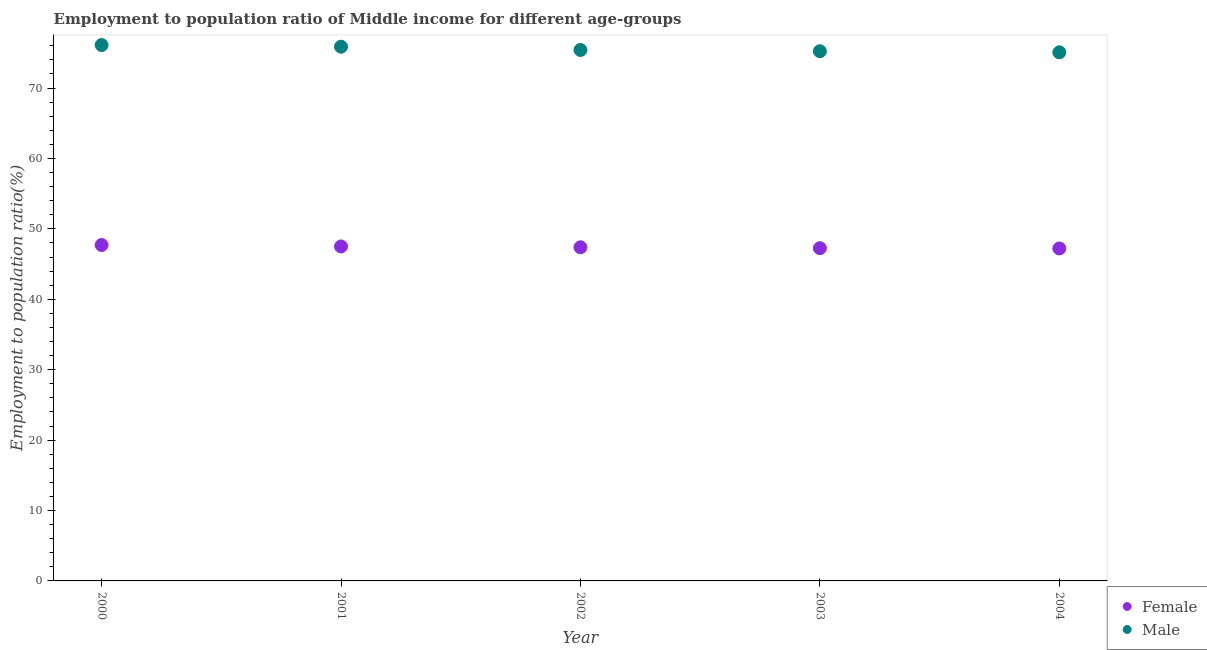What is the employment to population ratio(female) in 2001?
Give a very brief answer. 47.51. Across all years, what is the maximum employment to population ratio(male)?
Provide a succinct answer. 76.11. Across all years, what is the minimum employment to population ratio(male)?
Provide a succinct answer. 75.07. In which year was the employment to population ratio(female) maximum?
Offer a very short reply. 2000. In which year was the employment to population ratio(male) minimum?
Provide a short and direct response. 2004. What is the total employment to population ratio(female) in the graph?
Provide a short and direct response. 237.08. What is the difference between the employment to population ratio(female) in 2002 and that in 2003?
Ensure brevity in your answer.  0.13. What is the difference between the employment to population ratio(female) in 2001 and the employment to population ratio(male) in 2002?
Offer a terse response. -27.9. What is the average employment to population ratio(female) per year?
Make the answer very short. 47.42. In the year 2000, what is the difference between the employment to population ratio(female) and employment to population ratio(male)?
Provide a succinct answer. -28.4. What is the ratio of the employment to population ratio(male) in 2000 to that in 2003?
Provide a succinct answer. 1.01. Is the employment to population ratio(female) in 2000 less than that in 2004?
Your response must be concise. No. What is the difference between the highest and the second highest employment to population ratio(female)?
Offer a very short reply. 0.2. What is the difference between the highest and the lowest employment to population ratio(female)?
Provide a succinct answer. 0.49. Is the sum of the employment to population ratio(male) in 2001 and 2002 greater than the maximum employment to population ratio(female) across all years?
Offer a terse response. Yes. Does the employment to population ratio(female) monotonically increase over the years?
Your answer should be very brief. No. Is the employment to population ratio(male) strictly less than the employment to population ratio(female) over the years?
Your answer should be very brief. No. How many dotlines are there?
Ensure brevity in your answer.  2. How many years are there in the graph?
Keep it short and to the point. 5. Does the graph contain any zero values?
Offer a terse response. No. Does the graph contain grids?
Offer a terse response. No. Where does the legend appear in the graph?
Make the answer very short. Bottom right. How many legend labels are there?
Your answer should be compact. 2. How are the legend labels stacked?
Your answer should be very brief. Vertical. What is the title of the graph?
Keep it short and to the point. Employment to population ratio of Middle income for different age-groups. Does "Urban Population" appear as one of the legend labels in the graph?
Offer a very short reply. No. What is the label or title of the X-axis?
Your response must be concise. Year. What is the label or title of the Y-axis?
Give a very brief answer. Employment to population ratio(%). What is the Employment to population ratio(%) in Female in 2000?
Provide a short and direct response. 47.71. What is the Employment to population ratio(%) in Male in 2000?
Ensure brevity in your answer.  76.11. What is the Employment to population ratio(%) in Female in 2001?
Give a very brief answer. 47.51. What is the Employment to population ratio(%) in Male in 2001?
Make the answer very short. 75.88. What is the Employment to population ratio(%) in Female in 2002?
Your answer should be very brief. 47.39. What is the Employment to population ratio(%) in Male in 2002?
Keep it short and to the point. 75.41. What is the Employment to population ratio(%) in Female in 2003?
Your answer should be compact. 47.26. What is the Employment to population ratio(%) in Male in 2003?
Offer a terse response. 75.23. What is the Employment to population ratio(%) in Female in 2004?
Provide a succinct answer. 47.22. What is the Employment to population ratio(%) in Male in 2004?
Make the answer very short. 75.07. Across all years, what is the maximum Employment to population ratio(%) in Female?
Your answer should be very brief. 47.71. Across all years, what is the maximum Employment to population ratio(%) in Male?
Provide a succinct answer. 76.11. Across all years, what is the minimum Employment to population ratio(%) of Female?
Your answer should be very brief. 47.22. Across all years, what is the minimum Employment to population ratio(%) in Male?
Ensure brevity in your answer.  75.07. What is the total Employment to population ratio(%) in Female in the graph?
Give a very brief answer. 237.08. What is the total Employment to population ratio(%) of Male in the graph?
Your response must be concise. 377.7. What is the difference between the Employment to population ratio(%) of Female in 2000 and that in 2001?
Make the answer very short. 0.2. What is the difference between the Employment to population ratio(%) of Male in 2000 and that in 2001?
Ensure brevity in your answer.  0.23. What is the difference between the Employment to population ratio(%) of Female in 2000 and that in 2002?
Make the answer very short. 0.32. What is the difference between the Employment to population ratio(%) in Male in 2000 and that in 2002?
Your answer should be very brief. 0.7. What is the difference between the Employment to population ratio(%) in Female in 2000 and that in 2003?
Provide a succinct answer. 0.45. What is the difference between the Employment to population ratio(%) in Male in 2000 and that in 2003?
Provide a short and direct response. 0.88. What is the difference between the Employment to population ratio(%) in Female in 2000 and that in 2004?
Ensure brevity in your answer.  0.49. What is the difference between the Employment to population ratio(%) of Male in 2000 and that in 2004?
Provide a succinct answer. 1.03. What is the difference between the Employment to population ratio(%) in Female in 2001 and that in 2002?
Make the answer very short. 0.12. What is the difference between the Employment to population ratio(%) in Male in 2001 and that in 2002?
Ensure brevity in your answer.  0.47. What is the difference between the Employment to population ratio(%) of Female in 2001 and that in 2003?
Your answer should be compact. 0.25. What is the difference between the Employment to population ratio(%) in Male in 2001 and that in 2003?
Make the answer very short. 0.64. What is the difference between the Employment to population ratio(%) of Female in 2001 and that in 2004?
Make the answer very short. 0.28. What is the difference between the Employment to population ratio(%) in Male in 2001 and that in 2004?
Offer a terse response. 0.8. What is the difference between the Employment to population ratio(%) of Female in 2002 and that in 2003?
Your answer should be compact. 0.13. What is the difference between the Employment to population ratio(%) in Male in 2002 and that in 2003?
Provide a short and direct response. 0.18. What is the difference between the Employment to population ratio(%) of Female in 2002 and that in 2004?
Offer a very short reply. 0.17. What is the difference between the Employment to population ratio(%) in Male in 2002 and that in 2004?
Provide a succinct answer. 0.33. What is the difference between the Employment to population ratio(%) of Female in 2003 and that in 2004?
Keep it short and to the point. 0.04. What is the difference between the Employment to population ratio(%) of Male in 2003 and that in 2004?
Offer a very short reply. 0.16. What is the difference between the Employment to population ratio(%) of Female in 2000 and the Employment to population ratio(%) of Male in 2001?
Your answer should be very brief. -28.17. What is the difference between the Employment to population ratio(%) in Female in 2000 and the Employment to population ratio(%) in Male in 2002?
Keep it short and to the point. -27.7. What is the difference between the Employment to population ratio(%) in Female in 2000 and the Employment to population ratio(%) in Male in 2003?
Make the answer very short. -27.52. What is the difference between the Employment to population ratio(%) of Female in 2000 and the Employment to population ratio(%) of Male in 2004?
Ensure brevity in your answer.  -27.37. What is the difference between the Employment to population ratio(%) in Female in 2001 and the Employment to population ratio(%) in Male in 2002?
Provide a short and direct response. -27.9. What is the difference between the Employment to population ratio(%) of Female in 2001 and the Employment to population ratio(%) of Male in 2003?
Keep it short and to the point. -27.73. What is the difference between the Employment to population ratio(%) of Female in 2001 and the Employment to population ratio(%) of Male in 2004?
Your response must be concise. -27.57. What is the difference between the Employment to population ratio(%) of Female in 2002 and the Employment to population ratio(%) of Male in 2003?
Give a very brief answer. -27.84. What is the difference between the Employment to population ratio(%) of Female in 2002 and the Employment to population ratio(%) of Male in 2004?
Provide a succinct answer. -27.69. What is the difference between the Employment to population ratio(%) in Female in 2003 and the Employment to population ratio(%) in Male in 2004?
Offer a terse response. -27.82. What is the average Employment to population ratio(%) in Female per year?
Offer a very short reply. 47.42. What is the average Employment to population ratio(%) of Male per year?
Make the answer very short. 75.54. In the year 2000, what is the difference between the Employment to population ratio(%) in Female and Employment to population ratio(%) in Male?
Make the answer very short. -28.4. In the year 2001, what is the difference between the Employment to population ratio(%) in Female and Employment to population ratio(%) in Male?
Make the answer very short. -28.37. In the year 2002, what is the difference between the Employment to population ratio(%) of Female and Employment to population ratio(%) of Male?
Keep it short and to the point. -28.02. In the year 2003, what is the difference between the Employment to population ratio(%) of Female and Employment to population ratio(%) of Male?
Provide a short and direct response. -27.97. In the year 2004, what is the difference between the Employment to population ratio(%) of Female and Employment to population ratio(%) of Male?
Provide a succinct answer. -27.85. What is the ratio of the Employment to population ratio(%) in Male in 2000 to that in 2001?
Ensure brevity in your answer.  1. What is the ratio of the Employment to population ratio(%) of Female in 2000 to that in 2002?
Ensure brevity in your answer.  1.01. What is the ratio of the Employment to population ratio(%) in Male in 2000 to that in 2002?
Your answer should be compact. 1.01. What is the ratio of the Employment to population ratio(%) in Female in 2000 to that in 2003?
Ensure brevity in your answer.  1.01. What is the ratio of the Employment to population ratio(%) in Male in 2000 to that in 2003?
Your answer should be compact. 1.01. What is the ratio of the Employment to population ratio(%) of Female in 2000 to that in 2004?
Provide a succinct answer. 1.01. What is the ratio of the Employment to population ratio(%) of Male in 2000 to that in 2004?
Your response must be concise. 1.01. What is the ratio of the Employment to population ratio(%) of Female in 2001 to that in 2002?
Ensure brevity in your answer.  1. What is the ratio of the Employment to population ratio(%) in Male in 2001 to that in 2002?
Make the answer very short. 1.01. What is the ratio of the Employment to population ratio(%) in Male in 2001 to that in 2003?
Make the answer very short. 1.01. What is the ratio of the Employment to population ratio(%) in Male in 2001 to that in 2004?
Provide a short and direct response. 1.01. What is the ratio of the Employment to population ratio(%) in Female in 2003 to that in 2004?
Provide a short and direct response. 1. What is the difference between the highest and the second highest Employment to population ratio(%) in Female?
Your answer should be compact. 0.2. What is the difference between the highest and the second highest Employment to population ratio(%) in Male?
Give a very brief answer. 0.23. What is the difference between the highest and the lowest Employment to population ratio(%) of Female?
Offer a very short reply. 0.49. What is the difference between the highest and the lowest Employment to population ratio(%) of Male?
Your answer should be compact. 1.03. 